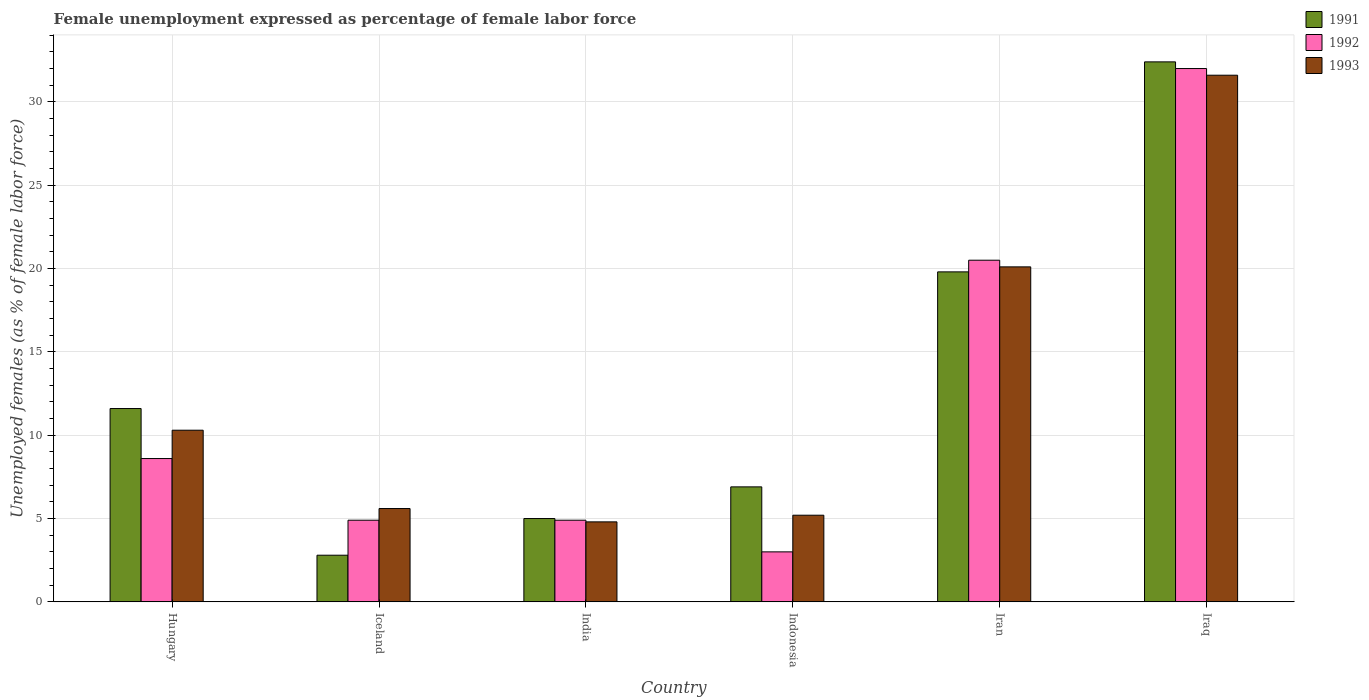How many different coloured bars are there?
Give a very brief answer. 3. Are the number of bars per tick equal to the number of legend labels?
Offer a very short reply. Yes. What is the label of the 5th group of bars from the left?
Your response must be concise. Iran. What is the unemployment in females in in 1993 in Indonesia?
Provide a short and direct response. 5.2. Across all countries, what is the maximum unemployment in females in in 1993?
Your response must be concise. 31.6. Across all countries, what is the minimum unemployment in females in in 1993?
Your response must be concise. 4.8. In which country was the unemployment in females in in 1991 maximum?
Offer a very short reply. Iraq. In which country was the unemployment in females in in 1991 minimum?
Offer a very short reply. Iceland. What is the total unemployment in females in in 1991 in the graph?
Provide a succinct answer. 78.5. What is the difference between the unemployment in females in in 1991 in Hungary and that in Iceland?
Ensure brevity in your answer.  8.8. What is the difference between the unemployment in females in in 1993 in Iceland and the unemployment in females in in 1991 in Iraq?
Offer a terse response. -26.8. What is the average unemployment in females in in 1991 per country?
Offer a very short reply. 13.08. What is the difference between the unemployment in females in of/in 1991 and unemployment in females in of/in 1992 in India?
Provide a succinct answer. 0.1. In how many countries, is the unemployment in females in in 1991 greater than 19 %?
Offer a very short reply. 2. What is the ratio of the unemployment in females in in 1991 in India to that in Iran?
Your response must be concise. 0.25. Is the difference between the unemployment in females in in 1991 in Hungary and Iraq greater than the difference between the unemployment in females in in 1992 in Hungary and Iraq?
Give a very brief answer. Yes. What is the difference between the highest and the second highest unemployment in females in in 1991?
Your answer should be compact. 12.6. What is the difference between the highest and the lowest unemployment in females in in 1991?
Provide a succinct answer. 29.6. Is the sum of the unemployment in females in in 1992 in Iceland and Iraq greater than the maximum unemployment in females in in 1993 across all countries?
Offer a terse response. Yes. What does the 2nd bar from the right in Iceland represents?
Your answer should be compact. 1992. Is it the case that in every country, the sum of the unemployment in females in in 1992 and unemployment in females in in 1993 is greater than the unemployment in females in in 1991?
Your answer should be very brief. Yes. Are all the bars in the graph horizontal?
Ensure brevity in your answer.  No. Are the values on the major ticks of Y-axis written in scientific E-notation?
Offer a very short reply. No. Does the graph contain any zero values?
Ensure brevity in your answer.  No. Does the graph contain grids?
Provide a succinct answer. Yes. What is the title of the graph?
Keep it short and to the point. Female unemployment expressed as percentage of female labor force. Does "2014" appear as one of the legend labels in the graph?
Your response must be concise. No. What is the label or title of the X-axis?
Offer a terse response. Country. What is the label or title of the Y-axis?
Your response must be concise. Unemployed females (as % of female labor force). What is the Unemployed females (as % of female labor force) in 1991 in Hungary?
Offer a terse response. 11.6. What is the Unemployed females (as % of female labor force) of 1992 in Hungary?
Provide a succinct answer. 8.6. What is the Unemployed females (as % of female labor force) of 1993 in Hungary?
Give a very brief answer. 10.3. What is the Unemployed females (as % of female labor force) in 1991 in Iceland?
Give a very brief answer. 2.8. What is the Unemployed females (as % of female labor force) in 1992 in Iceland?
Offer a terse response. 4.9. What is the Unemployed females (as % of female labor force) in 1993 in Iceland?
Your response must be concise. 5.6. What is the Unemployed females (as % of female labor force) of 1991 in India?
Your answer should be very brief. 5. What is the Unemployed females (as % of female labor force) of 1992 in India?
Ensure brevity in your answer.  4.9. What is the Unemployed females (as % of female labor force) of 1993 in India?
Ensure brevity in your answer.  4.8. What is the Unemployed females (as % of female labor force) of 1991 in Indonesia?
Make the answer very short. 6.9. What is the Unemployed females (as % of female labor force) in 1993 in Indonesia?
Keep it short and to the point. 5.2. What is the Unemployed females (as % of female labor force) of 1991 in Iran?
Make the answer very short. 19.8. What is the Unemployed females (as % of female labor force) in 1993 in Iran?
Offer a very short reply. 20.1. What is the Unemployed females (as % of female labor force) of 1991 in Iraq?
Your answer should be compact. 32.4. What is the Unemployed females (as % of female labor force) of 1992 in Iraq?
Give a very brief answer. 32. What is the Unemployed females (as % of female labor force) in 1993 in Iraq?
Make the answer very short. 31.6. Across all countries, what is the maximum Unemployed females (as % of female labor force) of 1991?
Offer a very short reply. 32.4. Across all countries, what is the maximum Unemployed females (as % of female labor force) in 1993?
Offer a very short reply. 31.6. Across all countries, what is the minimum Unemployed females (as % of female labor force) of 1991?
Keep it short and to the point. 2.8. Across all countries, what is the minimum Unemployed females (as % of female labor force) of 1992?
Provide a succinct answer. 3. Across all countries, what is the minimum Unemployed females (as % of female labor force) in 1993?
Offer a terse response. 4.8. What is the total Unemployed females (as % of female labor force) of 1991 in the graph?
Keep it short and to the point. 78.5. What is the total Unemployed females (as % of female labor force) in 1992 in the graph?
Offer a terse response. 73.9. What is the total Unemployed females (as % of female labor force) of 1993 in the graph?
Ensure brevity in your answer.  77.6. What is the difference between the Unemployed females (as % of female labor force) in 1991 in Hungary and that in Iceland?
Make the answer very short. 8.8. What is the difference between the Unemployed females (as % of female labor force) of 1992 in Hungary and that in India?
Give a very brief answer. 3.7. What is the difference between the Unemployed females (as % of female labor force) in 1993 in Hungary and that in India?
Keep it short and to the point. 5.5. What is the difference between the Unemployed females (as % of female labor force) of 1991 in Hungary and that in Indonesia?
Provide a succinct answer. 4.7. What is the difference between the Unemployed females (as % of female labor force) of 1992 in Hungary and that in Indonesia?
Make the answer very short. 5.6. What is the difference between the Unemployed females (as % of female labor force) of 1991 in Hungary and that in Iran?
Provide a succinct answer. -8.2. What is the difference between the Unemployed females (as % of female labor force) in 1993 in Hungary and that in Iran?
Your answer should be compact. -9.8. What is the difference between the Unemployed females (as % of female labor force) of 1991 in Hungary and that in Iraq?
Your answer should be very brief. -20.8. What is the difference between the Unemployed females (as % of female labor force) of 1992 in Hungary and that in Iraq?
Make the answer very short. -23.4. What is the difference between the Unemployed females (as % of female labor force) of 1993 in Hungary and that in Iraq?
Your answer should be very brief. -21.3. What is the difference between the Unemployed females (as % of female labor force) of 1991 in Iceland and that in India?
Make the answer very short. -2.2. What is the difference between the Unemployed females (as % of female labor force) in 1993 in Iceland and that in Indonesia?
Your response must be concise. 0.4. What is the difference between the Unemployed females (as % of female labor force) of 1992 in Iceland and that in Iran?
Your answer should be very brief. -15.6. What is the difference between the Unemployed females (as % of female labor force) in 1991 in Iceland and that in Iraq?
Ensure brevity in your answer.  -29.6. What is the difference between the Unemployed females (as % of female labor force) in 1992 in Iceland and that in Iraq?
Provide a short and direct response. -27.1. What is the difference between the Unemployed females (as % of female labor force) of 1993 in Iceland and that in Iraq?
Your answer should be compact. -26. What is the difference between the Unemployed females (as % of female labor force) of 1993 in India and that in Indonesia?
Provide a short and direct response. -0.4. What is the difference between the Unemployed females (as % of female labor force) of 1991 in India and that in Iran?
Keep it short and to the point. -14.8. What is the difference between the Unemployed females (as % of female labor force) of 1992 in India and that in Iran?
Your response must be concise. -15.6. What is the difference between the Unemployed females (as % of female labor force) in 1993 in India and that in Iran?
Your answer should be compact. -15.3. What is the difference between the Unemployed females (as % of female labor force) of 1991 in India and that in Iraq?
Your answer should be very brief. -27.4. What is the difference between the Unemployed females (as % of female labor force) of 1992 in India and that in Iraq?
Your response must be concise. -27.1. What is the difference between the Unemployed females (as % of female labor force) in 1993 in India and that in Iraq?
Make the answer very short. -26.8. What is the difference between the Unemployed females (as % of female labor force) in 1991 in Indonesia and that in Iran?
Make the answer very short. -12.9. What is the difference between the Unemployed females (as % of female labor force) of 1992 in Indonesia and that in Iran?
Keep it short and to the point. -17.5. What is the difference between the Unemployed females (as % of female labor force) in 1993 in Indonesia and that in Iran?
Provide a short and direct response. -14.9. What is the difference between the Unemployed females (as % of female labor force) in 1991 in Indonesia and that in Iraq?
Make the answer very short. -25.5. What is the difference between the Unemployed females (as % of female labor force) of 1993 in Indonesia and that in Iraq?
Ensure brevity in your answer.  -26.4. What is the difference between the Unemployed females (as % of female labor force) of 1992 in Iran and that in Iraq?
Offer a very short reply. -11.5. What is the difference between the Unemployed females (as % of female labor force) of 1991 in Hungary and the Unemployed females (as % of female labor force) of 1992 in Iceland?
Give a very brief answer. 6.7. What is the difference between the Unemployed females (as % of female labor force) of 1991 in Hungary and the Unemployed females (as % of female labor force) of 1992 in India?
Keep it short and to the point. 6.7. What is the difference between the Unemployed females (as % of female labor force) of 1991 in Hungary and the Unemployed females (as % of female labor force) of 1993 in India?
Your response must be concise. 6.8. What is the difference between the Unemployed females (as % of female labor force) in 1992 in Hungary and the Unemployed females (as % of female labor force) in 1993 in India?
Keep it short and to the point. 3.8. What is the difference between the Unemployed females (as % of female labor force) in 1991 in Hungary and the Unemployed females (as % of female labor force) in 1993 in Indonesia?
Make the answer very short. 6.4. What is the difference between the Unemployed females (as % of female labor force) in 1992 in Hungary and the Unemployed females (as % of female labor force) in 1993 in Indonesia?
Your response must be concise. 3.4. What is the difference between the Unemployed females (as % of female labor force) of 1991 in Hungary and the Unemployed females (as % of female labor force) of 1993 in Iran?
Offer a very short reply. -8.5. What is the difference between the Unemployed females (as % of female labor force) in 1991 in Hungary and the Unemployed females (as % of female labor force) in 1992 in Iraq?
Your answer should be very brief. -20.4. What is the difference between the Unemployed females (as % of female labor force) of 1991 in Hungary and the Unemployed females (as % of female labor force) of 1993 in Iraq?
Your answer should be very brief. -20. What is the difference between the Unemployed females (as % of female labor force) in 1992 in Hungary and the Unemployed females (as % of female labor force) in 1993 in Iraq?
Offer a terse response. -23. What is the difference between the Unemployed females (as % of female labor force) in 1991 in Iceland and the Unemployed females (as % of female labor force) in 1992 in India?
Make the answer very short. -2.1. What is the difference between the Unemployed females (as % of female labor force) in 1991 in Iceland and the Unemployed females (as % of female labor force) in 1993 in India?
Make the answer very short. -2. What is the difference between the Unemployed females (as % of female labor force) in 1992 in Iceland and the Unemployed females (as % of female labor force) in 1993 in India?
Provide a succinct answer. 0.1. What is the difference between the Unemployed females (as % of female labor force) in 1991 in Iceland and the Unemployed females (as % of female labor force) in 1992 in Indonesia?
Your answer should be compact. -0.2. What is the difference between the Unemployed females (as % of female labor force) in 1991 in Iceland and the Unemployed females (as % of female labor force) in 1992 in Iran?
Make the answer very short. -17.7. What is the difference between the Unemployed females (as % of female labor force) in 1991 in Iceland and the Unemployed females (as % of female labor force) in 1993 in Iran?
Offer a terse response. -17.3. What is the difference between the Unemployed females (as % of female labor force) in 1992 in Iceland and the Unemployed females (as % of female labor force) in 1993 in Iran?
Provide a succinct answer. -15.2. What is the difference between the Unemployed females (as % of female labor force) of 1991 in Iceland and the Unemployed females (as % of female labor force) of 1992 in Iraq?
Your response must be concise. -29.2. What is the difference between the Unemployed females (as % of female labor force) of 1991 in Iceland and the Unemployed females (as % of female labor force) of 1993 in Iraq?
Offer a very short reply. -28.8. What is the difference between the Unemployed females (as % of female labor force) in 1992 in Iceland and the Unemployed females (as % of female labor force) in 1993 in Iraq?
Ensure brevity in your answer.  -26.7. What is the difference between the Unemployed females (as % of female labor force) in 1991 in India and the Unemployed females (as % of female labor force) in 1992 in Indonesia?
Offer a terse response. 2. What is the difference between the Unemployed females (as % of female labor force) in 1991 in India and the Unemployed females (as % of female labor force) in 1993 in Indonesia?
Provide a short and direct response. -0.2. What is the difference between the Unemployed females (as % of female labor force) of 1991 in India and the Unemployed females (as % of female labor force) of 1992 in Iran?
Your answer should be compact. -15.5. What is the difference between the Unemployed females (as % of female labor force) of 1991 in India and the Unemployed females (as % of female labor force) of 1993 in Iran?
Offer a very short reply. -15.1. What is the difference between the Unemployed females (as % of female labor force) in 1992 in India and the Unemployed females (as % of female labor force) in 1993 in Iran?
Give a very brief answer. -15.2. What is the difference between the Unemployed females (as % of female labor force) in 1991 in India and the Unemployed females (as % of female labor force) in 1993 in Iraq?
Keep it short and to the point. -26.6. What is the difference between the Unemployed females (as % of female labor force) of 1992 in India and the Unemployed females (as % of female labor force) of 1993 in Iraq?
Offer a terse response. -26.7. What is the difference between the Unemployed females (as % of female labor force) of 1991 in Indonesia and the Unemployed females (as % of female labor force) of 1992 in Iran?
Keep it short and to the point. -13.6. What is the difference between the Unemployed females (as % of female labor force) of 1992 in Indonesia and the Unemployed females (as % of female labor force) of 1993 in Iran?
Give a very brief answer. -17.1. What is the difference between the Unemployed females (as % of female labor force) of 1991 in Indonesia and the Unemployed females (as % of female labor force) of 1992 in Iraq?
Your answer should be compact. -25.1. What is the difference between the Unemployed females (as % of female labor force) of 1991 in Indonesia and the Unemployed females (as % of female labor force) of 1993 in Iraq?
Make the answer very short. -24.7. What is the difference between the Unemployed females (as % of female labor force) of 1992 in Indonesia and the Unemployed females (as % of female labor force) of 1993 in Iraq?
Your answer should be very brief. -28.6. What is the difference between the Unemployed females (as % of female labor force) of 1991 in Iran and the Unemployed females (as % of female labor force) of 1993 in Iraq?
Keep it short and to the point. -11.8. What is the average Unemployed females (as % of female labor force) of 1991 per country?
Your response must be concise. 13.08. What is the average Unemployed females (as % of female labor force) of 1992 per country?
Give a very brief answer. 12.32. What is the average Unemployed females (as % of female labor force) in 1993 per country?
Make the answer very short. 12.93. What is the difference between the Unemployed females (as % of female labor force) of 1991 and Unemployed females (as % of female labor force) of 1992 in Hungary?
Ensure brevity in your answer.  3. What is the difference between the Unemployed females (as % of female labor force) in 1991 and Unemployed females (as % of female labor force) in 1993 in Hungary?
Provide a succinct answer. 1.3. What is the difference between the Unemployed females (as % of female labor force) of 1992 and Unemployed females (as % of female labor force) of 1993 in Hungary?
Your answer should be compact. -1.7. What is the difference between the Unemployed females (as % of female labor force) in 1991 and Unemployed females (as % of female labor force) in 1993 in India?
Keep it short and to the point. 0.2. What is the difference between the Unemployed females (as % of female labor force) in 1991 and Unemployed females (as % of female labor force) in 1992 in Indonesia?
Your response must be concise. 3.9. What is the difference between the Unemployed females (as % of female labor force) in 1991 and Unemployed females (as % of female labor force) in 1993 in Indonesia?
Keep it short and to the point. 1.7. What is the difference between the Unemployed females (as % of female labor force) in 1991 and Unemployed females (as % of female labor force) in 1992 in Iran?
Provide a short and direct response. -0.7. What is the difference between the Unemployed females (as % of female labor force) in 1991 and Unemployed females (as % of female labor force) in 1993 in Iran?
Ensure brevity in your answer.  -0.3. What is the ratio of the Unemployed females (as % of female labor force) of 1991 in Hungary to that in Iceland?
Your answer should be very brief. 4.14. What is the ratio of the Unemployed females (as % of female labor force) in 1992 in Hungary to that in Iceland?
Your answer should be very brief. 1.76. What is the ratio of the Unemployed females (as % of female labor force) in 1993 in Hungary to that in Iceland?
Keep it short and to the point. 1.84. What is the ratio of the Unemployed females (as % of female labor force) in 1991 in Hungary to that in India?
Offer a very short reply. 2.32. What is the ratio of the Unemployed females (as % of female labor force) in 1992 in Hungary to that in India?
Provide a succinct answer. 1.76. What is the ratio of the Unemployed females (as % of female labor force) of 1993 in Hungary to that in India?
Give a very brief answer. 2.15. What is the ratio of the Unemployed females (as % of female labor force) in 1991 in Hungary to that in Indonesia?
Keep it short and to the point. 1.68. What is the ratio of the Unemployed females (as % of female labor force) in 1992 in Hungary to that in Indonesia?
Provide a short and direct response. 2.87. What is the ratio of the Unemployed females (as % of female labor force) of 1993 in Hungary to that in Indonesia?
Make the answer very short. 1.98. What is the ratio of the Unemployed females (as % of female labor force) in 1991 in Hungary to that in Iran?
Ensure brevity in your answer.  0.59. What is the ratio of the Unemployed females (as % of female labor force) of 1992 in Hungary to that in Iran?
Your answer should be compact. 0.42. What is the ratio of the Unemployed females (as % of female labor force) in 1993 in Hungary to that in Iran?
Provide a succinct answer. 0.51. What is the ratio of the Unemployed females (as % of female labor force) in 1991 in Hungary to that in Iraq?
Your answer should be compact. 0.36. What is the ratio of the Unemployed females (as % of female labor force) of 1992 in Hungary to that in Iraq?
Give a very brief answer. 0.27. What is the ratio of the Unemployed females (as % of female labor force) of 1993 in Hungary to that in Iraq?
Provide a succinct answer. 0.33. What is the ratio of the Unemployed females (as % of female labor force) of 1991 in Iceland to that in India?
Your answer should be very brief. 0.56. What is the ratio of the Unemployed females (as % of female labor force) in 1993 in Iceland to that in India?
Offer a terse response. 1.17. What is the ratio of the Unemployed females (as % of female labor force) in 1991 in Iceland to that in Indonesia?
Keep it short and to the point. 0.41. What is the ratio of the Unemployed females (as % of female labor force) in 1992 in Iceland to that in Indonesia?
Your response must be concise. 1.63. What is the ratio of the Unemployed females (as % of female labor force) of 1991 in Iceland to that in Iran?
Your answer should be compact. 0.14. What is the ratio of the Unemployed females (as % of female labor force) in 1992 in Iceland to that in Iran?
Your answer should be compact. 0.24. What is the ratio of the Unemployed females (as % of female labor force) of 1993 in Iceland to that in Iran?
Give a very brief answer. 0.28. What is the ratio of the Unemployed females (as % of female labor force) in 1991 in Iceland to that in Iraq?
Offer a terse response. 0.09. What is the ratio of the Unemployed females (as % of female labor force) in 1992 in Iceland to that in Iraq?
Offer a very short reply. 0.15. What is the ratio of the Unemployed females (as % of female labor force) in 1993 in Iceland to that in Iraq?
Provide a succinct answer. 0.18. What is the ratio of the Unemployed females (as % of female labor force) of 1991 in India to that in Indonesia?
Offer a very short reply. 0.72. What is the ratio of the Unemployed females (as % of female labor force) of 1992 in India to that in Indonesia?
Keep it short and to the point. 1.63. What is the ratio of the Unemployed females (as % of female labor force) of 1991 in India to that in Iran?
Offer a very short reply. 0.25. What is the ratio of the Unemployed females (as % of female labor force) of 1992 in India to that in Iran?
Offer a terse response. 0.24. What is the ratio of the Unemployed females (as % of female labor force) of 1993 in India to that in Iran?
Offer a very short reply. 0.24. What is the ratio of the Unemployed females (as % of female labor force) of 1991 in India to that in Iraq?
Your answer should be compact. 0.15. What is the ratio of the Unemployed females (as % of female labor force) in 1992 in India to that in Iraq?
Your response must be concise. 0.15. What is the ratio of the Unemployed females (as % of female labor force) of 1993 in India to that in Iraq?
Provide a short and direct response. 0.15. What is the ratio of the Unemployed females (as % of female labor force) in 1991 in Indonesia to that in Iran?
Your answer should be compact. 0.35. What is the ratio of the Unemployed females (as % of female labor force) in 1992 in Indonesia to that in Iran?
Offer a terse response. 0.15. What is the ratio of the Unemployed females (as % of female labor force) in 1993 in Indonesia to that in Iran?
Your answer should be compact. 0.26. What is the ratio of the Unemployed females (as % of female labor force) of 1991 in Indonesia to that in Iraq?
Provide a succinct answer. 0.21. What is the ratio of the Unemployed females (as % of female labor force) in 1992 in Indonesia to that in Iraq?
Offer a terse response. 0.09. What is the ratio of the Unemployed females (as % of female labor force) of 1993 in Indonesia to that in Iraq?
Ensure brevity in your answer.  0.16. What is the ratio of the Unemployed females (as % of female labor force) in 1991 in Iran to that in Iraq?
Ensure brevity in your answer.  0.61. What is the ratio of the Unemployed females (as % of female labor force) of 1992 in Iran to that in Iraq?
Your answer should be compact. 0.64. What is the ratio of the Unemployed females (as % of female labor force) of 1993 in Iran to that in Iraq?
Offer a terse response. 0.64. What is the difference between the highest and the second highest Unemployed females (as % of female labor force) in 1992?
Your response must be concise. 11.5. What is the difference between the highest and the lowest Unemployed females (as % of female labor force) of 1991?
Your answer should be compact. 29.6. What is the difference between the highest and the lowest Unemployed females (as % of female labor force) of 1992?
Your answer should be very brief. 29. What is the difference between the highest and the lowest Unemployed females (as % of female labor force) in 1993?
Your answer should be compact. 26.8. 